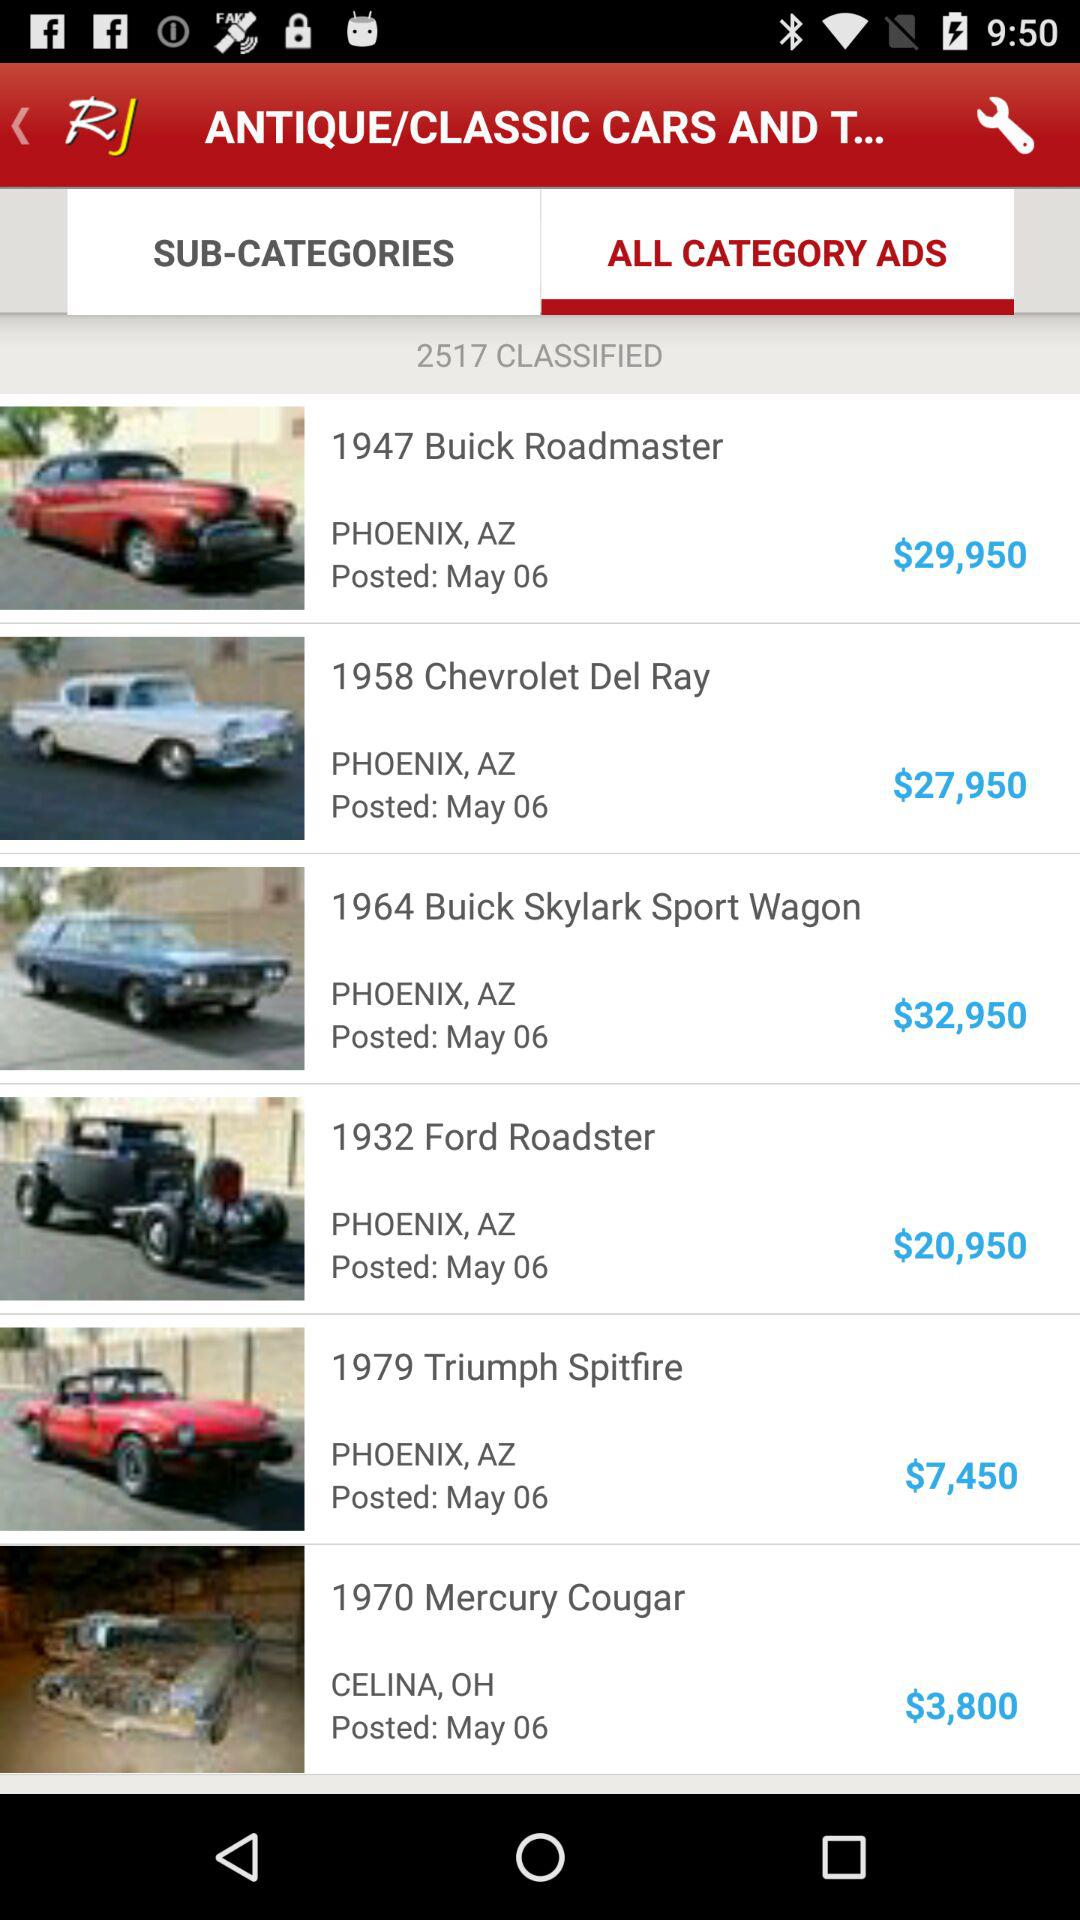What is the model year of "Roadmaster"? The model year is 1947. 